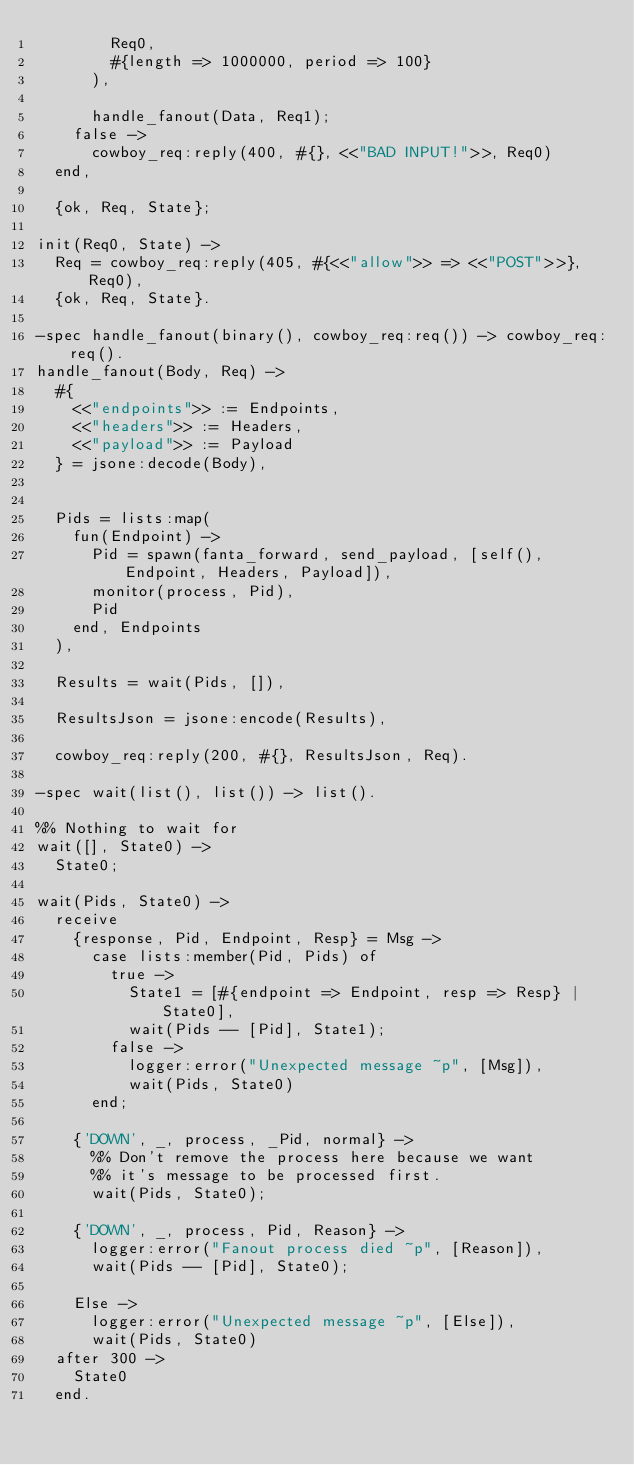<code> <loc_0><loc_0><loc_500><loc_500><_Erlang_>        Req0,
        #{length => 1000000, period => 100}
      ),

      handle_fanout(Data, Req1);
    false ->
      cowboy_req:reply(400, #{}, <<"BAD INPUT!">>, Req0)
  end,

  {ok, Req, State};

init(Req0, State) ->
  Req = cowboy_req:reply(405, #{<<"allow">> => <<"POST">>}, Req0),
  {ok, Req, State}.

-spec handle_fanout(binary(), cowboy_req:req()) -> cowboy_req:req().
handle_fanout(Body, Req) ->
  #{
    <<"endpoints">> := Endpoints,
    <<"headers">> := Headers,
    <<"payload">> := Payload
  } = jsone:decode(Body),


  Pids = lists:map(
    fun(Endpoint) ->
      Pid = spawn(fanta_forward, send_payload, [self(), Endpoint, Headers, Payload]),
      monitor(process, Pid),
      Pid
    end, Endpoints
  ),

  Results = wait(Pids, []),

  ResultsJson = jsone:encode(Results),

  cowboy_req:reply(200, #{}, ResultsJson, Req).

-spec wait(list(), list()) -> list().

%% Nothing to wait for
wait([], State0) ->
  State0;

wait(Pids, State0) ->
  receive
    {response, Pid, Endpoint, Resp} = Msg ->
      case lists:member(Pid, Pids) of
        true ->
          State1 = [#{endpoint => Endpoint, resp => Resp} | State0],
          wait(Pids -- [Pid], State1);
        false ->
          logger:error("Unexpected message ~p", [Msg]),
          wait(Pids, State0)
      end;

    {'DOWN', _, process, _Pid, normal} ->
      %% Don't remove the process here because we want
      %% it's message to be processed first.
      wait(Pids, State0);

    {'DOWN', _, process, Pid, Reason} ->
      logger:error("Fanout process died ~p", [Reason]),
      wait(Pids -- [Pid], State0);

    Else ->
      logger:error("Unexpected message ~p", [Else]),
      wait(Pids, State0)
  after 300 ->
    State0
  end.</code> 